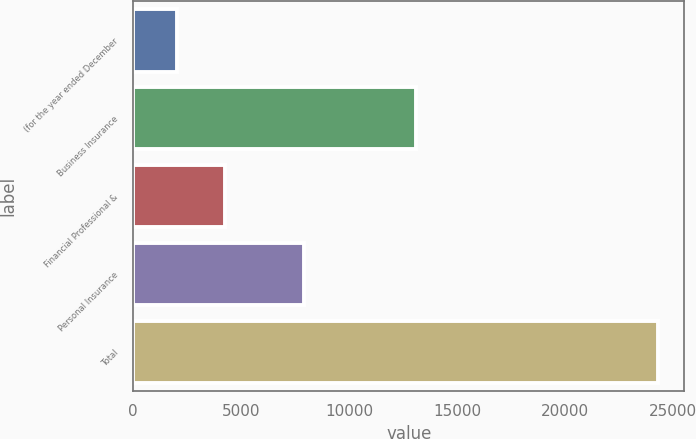Convert chart. <chart><loc_0><loc_0><loc_500><loc_500><bar_chart><fcel>(for the year ended December<fcel>Business Insurance<fcel>Financial Professional &<fcel>Personal Insurance<fcel>Total<nl><fcel>2012<fcel>13111<fcel>4241.7<fcel>7923<fcel>24309<nl></chart> 